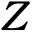Convert formula to latex. <formula><loc_0><loc_0><loc_500><loc_500>{ Z }</formula> 